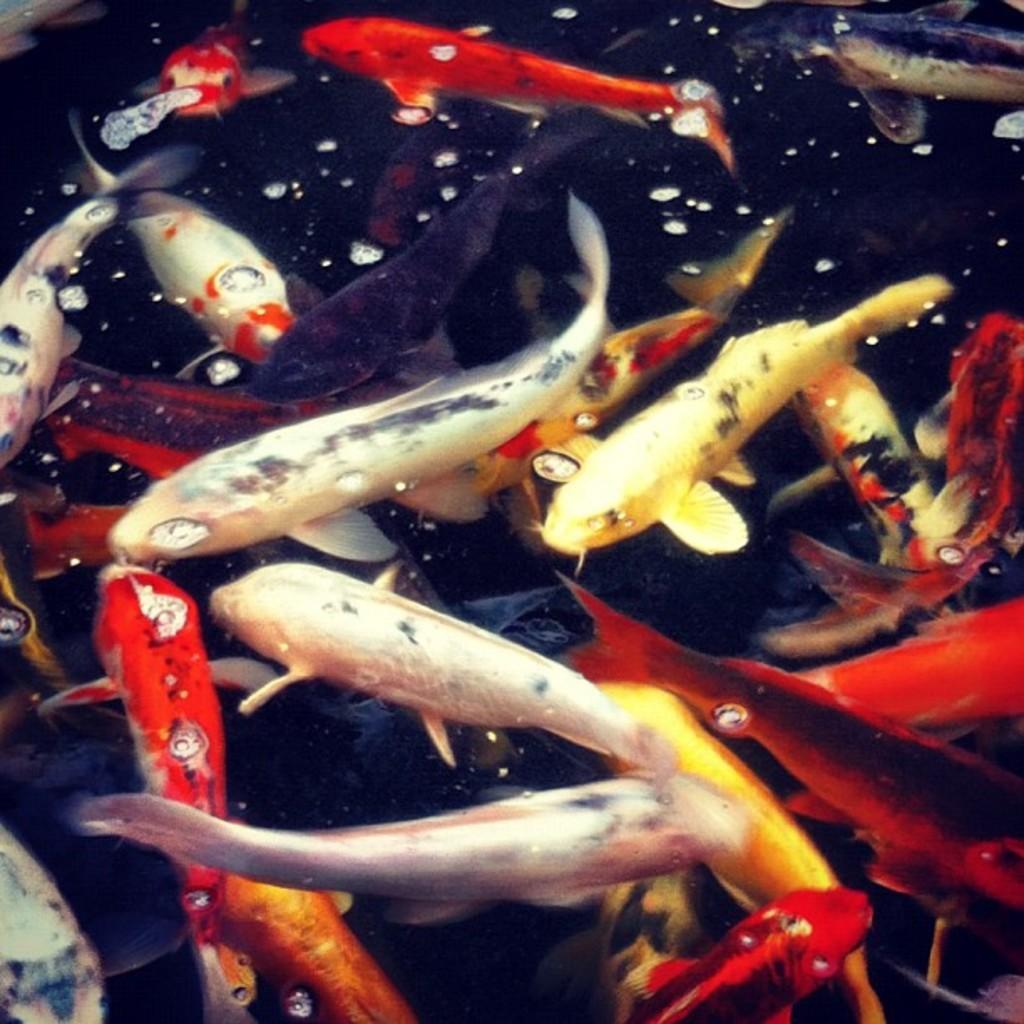Please provide a concise description of this image. In the image we can see some fishes in the water. 